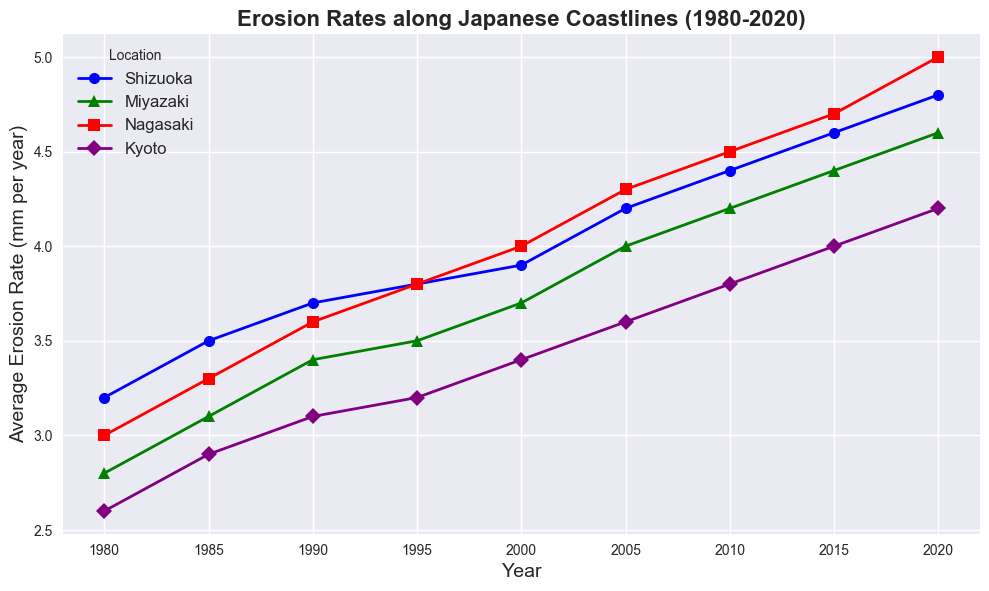How has the erosion rate in Shizuoka changed from 1980 to 2020? To find out how the erosion rate in Shizuoka has changed, we look at the starting and ending points on the line for Shizuoka, which is represented by a blue line with circular markers. In 1980, the rate was 3.2 mm/year, and by 2020, it had increased to 4.8 mm/year. The difference is 4.8 - 3.2 = 1.6 mm/year.
Answer: 1.6 mm/year Which location experienced the highest erosion rate in 2020? To determine the highest erosion rate in 2020, we look at the endpoints of each location's line. Nagasaki, represented by a red line with square markers, has an erosion rate of 5.0 mm/year in 2020. This is higher than the other locations.
Answer: Nagasaki Compare the erosion rates of Kyoto and Miyazaki in 2005. Which one is higher? To compare the erosion rates in 2005, look at the points on the lines corresponding to Kyoto and Miyazaki. For Kyoto (purple with diamond markers), the rate is 3.6 mm/year. For Miyazaki (green with triangle markers), the rate is 4.0 mm/year. Thus, Miyazaki has a higher erosion rate in 2005.
Answer: Miyazaki What is the average erosion rate in Nagasaki from 2010 to 2020? To find the average, sum the erosion rates for Nagasaki from 2010, 2015, and 2020 and divide by the number of years. The erosion rates are 4.5, 4.7, and 5.0 mm/year respectively. The total is 4.5 + 4.7 + 5.0 = 14.2 mm/year over 3 years. The average is 14.2 / 3 ≈ 4.73 mm/year.
Answer: ~4.73 mm/year What is the overall trend in erosion rates for Kyoto from 1980 to 2020? To determine the overall trend, we observe the purple line with diamond markers for Kyoto. Starting at 2.6 mm/year in 1980, it steadily increases to 4.2 mm/year in 2020. This indicates a consistent upward trend.
Answer: Upward trend Which location had the smallest increase in erosion rate from 1980 to 2020? To determine the smallest increase, compare the difference in erosion rate for each location from 1980 to 2020. For Shizuoka: 4.8 - 3.2 = 1.6 mm/year, for Miyazaki: 4.6 - 2.8 = 1.8 mm/year, for Nagasaki: 5.0 - 3.0 = 2.0 mm/year, and for Kyoto: 4.2 - 2.6 = 1.6 mm/year. Both Shizuoka and Kyoto have the smallest increase of 1.6 mm/year.
Answer: Shizuoka and Kyoto In which decade did Shizuoka see the highest rise in erosion rate? Calculate the rise in erosion rate for each decade starting from 1980. 1980-1990: 3.7 - 3.2 = 0.5 mm/year, 1990-2000: 3.9 - 3.7 = 0.2 mm/year, 2000-2010: 4.4 - 3.9 = 0.5 mm/year, 2010-2020: 4.8 - 4.4 = 0.4 mm/year. The highest rise is in the decades 1980-1990 and 2000-2010 with an increase of 0.5 mm/year.
Answer: 1980-1990 and 2000-2010 Between 1990 and 2020, which location showed the most consistent increase in erosion rate? To find the most consistent increase, look for a location with the least variation in the rate of change per decade. Shizuoka (1990-2000: 0.2, 2000-2010: 0.5, 2010-2020: 0.4), Miyazaki (1990-2000: 0.3, 2000-2010: 0.4, 2010-2020: 0.4), Nagasaki (1990-2000: 0.4, 2000-2010: 0.5, 2010-2020: 0.5), Kyoto (1990-2000: 0.3, 2000-2010: 0.2, 2010-2020: 0.4). Miyazaki has the least variation.
Answer: Miyazaki 